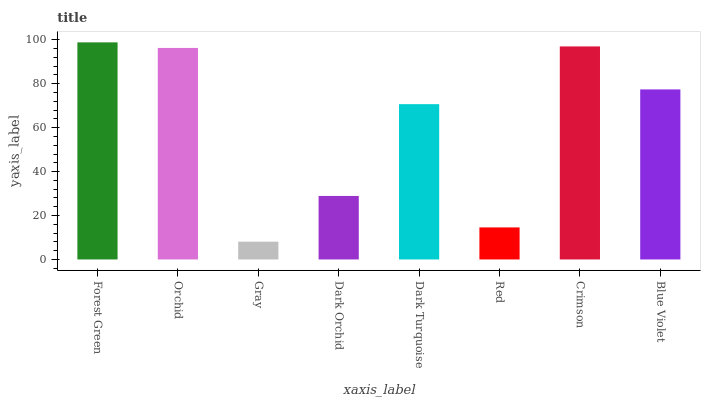Is Gray the minimum?
Answer yes or no. Yes. Is Forest Green the maximum?
Answer yes or no. Yes. Is Orchid the minimum?
Answer yes or no. No. Is Orchid the maximum?
Answer yes or no. No. Is Forest Green greater than Orchid?
Answer yes or no. Yes. Is Orchid less than Forest Green?
Answer yes or no. Yes. Is Orchid greater than Forest Green?
Answer yes or no. No. Is Forest Green less than Orchid?
Answer yes or no. No. Is Blue Violet the high median?
Answer yes or no. Yes. Is Dark Turquoise the low median?
Answer yes or no. Yes. Is Orchid the high median?
Answer yes or no. No. Is Crimson the low median?
Answer yes or no. No. 